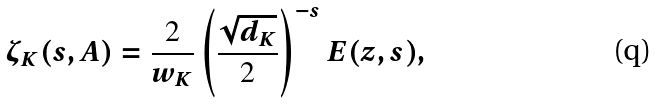Convert formula to latex. <formula><loc_0><loc_0><loc_500><loc_500>\zeta _ { K } ( s , A ) = \frac { 2 } { w _ { K } } \left ( \frac { \sqrt { d _ { K } } } { 2 } \right ) ^ { - s } E ( z , s ) ,</formula> 